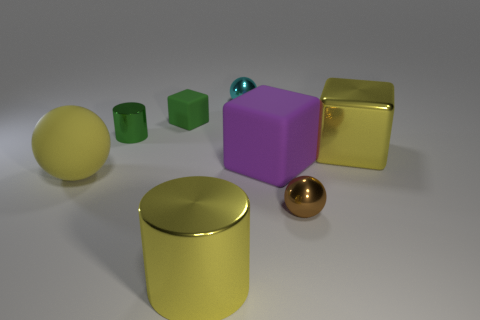Is the number of green cylinders in front of the large yellow metallic block the same as the number of cubes that are on the left side of the small brown sphere?
Keep it short and to the point. No. What number of other objects are the same color as the large matte block?
Keep it short and to the point. 0. Are there the same number of purple matte cubes that are on the right side of the tiny brown metal ball and big shiny blocks?
Give a very brief answer. No. Is the yellow cylinder the same size as the yellow block?
Make the answer very short. Yes. What material is the big thing that is both on the left side of the big purple matte block and to the right of the big rubber ball?
Provide a succinct answer. Metal. How many small metallic things are the same shape as the big yellow matte object?
Ensure brevity in your answer.  2. What material is the block that is to the left of the small cyan metallic object?
Offer a terse response. Rubber. Are there fewer brown metal balls behind the brown thing than large purple blocks?
Offer a terse response. Yes. Do the green shiny thing and the green matte thing have the same shape?
Offer a terse response. No. Is there anything else that has the same shape as the green rubber thing?
Your answer should be compact. Yes. 